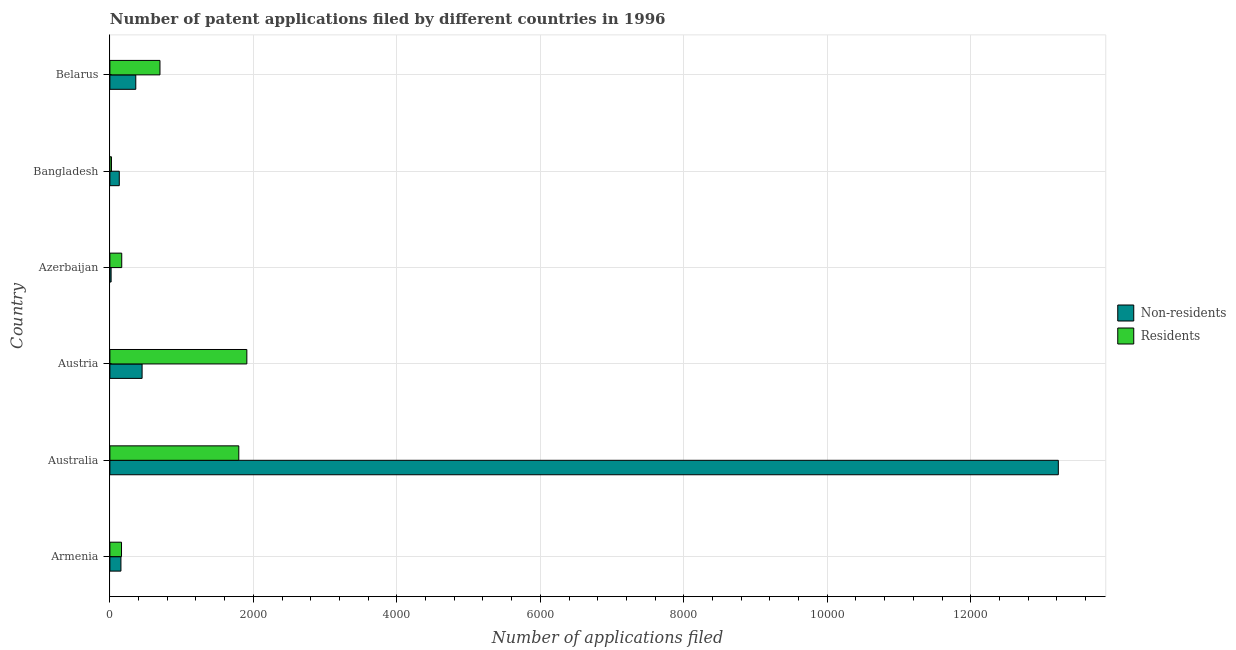How many groups of bars are there?
Ensure brevity in your answer.  6. Are the number of bars per tick equal to the number of legend labels?
Your response must be concise. Yes. Are the number of bars on each tick of the Y-axis equal?
Offer a terse response. Yes. How many bars are there on the 5th tick from the bottom?
Provide a succinct answer. 2. What is the label of the 3rd group of bars from the top?
Your answer should be very brief. Azerbaijan. What is the number of patent applications by residents in Armenia?
Keep it short and to the point. 162. Across all countries, what is the maximum number of patent applications by non residents?
Provide a succinct answer. 1.32e+04. Across all countries, what is the minimum number of patent applications by residents?
Ensure brevity in your answer.  22. In which country was the number of patent applications by non residents maximum?
Offer a very short reply. Australia. What is the total number of patent applications by residents in the graph?
Your answer should be very brief. 4753. What is the difference between the number of patent applications by residents in Australia and that in Belarus?
Provide a succinct answer. 1099. What is the difference between the number of patent applications by residents in Austria and the number of patent applications by non residents in Armenia?
Keep it short and to the point. 1755. What is the average number of patent applications by non residents per country?
Offer a terse response. 2388.83. What is the difference between the number of patent applications by residents and number of patent applications by non residents in Austria?
Give a very brief answer. 1460. In how many countries, is the number of patent applications by non residents greater than 8800 ?
Provide a succinct answer. 1. What is the ratio of the number of patent applications by non residents in Armenia to that in Australia?
Ensure brevity in your answer.  0.01. What is the difference between the highest and the second highest number of patent applications by residents?
Your answer should be very brief. 112. What is the difference between the highest and the lowest number of patent applications by non residents?
Give a very brief answer. 1.32e+04. Is the sum of the number of patent applications by non residents in Australia and Bangladesh greater than the maximum number of patent applications by residents across all countries?
Ensure brevity in your answer.  Yes. What does the 2nd bar from the top in Azerbaijan represents?
Your answer should be compact. Non-residents. What does the 2nd bar from the bottom in Austria represents?
Your answer should be compact. Residents. How many countries are there in the graph?
Provide a short and direct response. 6. Are the values on the major ticks of X-axis written in scientific E-notation?
Keep it short and to the point. No. Does the graph contain any zero values?
Your response must be concise. No. Does the graph contain grids?
Keep it short and to the point. Yes. How many legend labels are there?
Your answer should be very brief. 2. How are the legend labels stacked?
Your response must be concise. Vertical. What is the title of the graph?
Ensure brevity in your answer.  Number of patent applications filed by different countries in 1996. What is the label or title of the X-axis?
Ensure brevity in your answer.  Number of applications filed. What is the label or title of the Y-axis?
Your answer should be very brief. Country. What is the Number of applications filed of Non-residents in Armenia?
Offer a terse response. 154. What is the Number of applications filed of Residents in Armenia?
Offer a terse response. 162. What is the Number of applications filed of Non-residents in Australia?
Ensure brevity in your answer.  1.32e+04. What is the Number of applications filed of Residents in Australia?
Make the answer very short. 1797. What is the Number of applications filed in Non-residents in Austria?
Offer a terse response. 449. What is the Number of applications filed of Residents in Austria?
Provide a succinct answer. 1909. What is the Number of applications filed of Non-residents in Azerbaijan?
Your response must be concise. 17. What is the Number of applications filed of Residents in Azerbaijan?
Your answer should be very brief. 165. What is the Number of applications filed in Non-residents in Bangladesh?
Offer a very short reply. 131. What is the Number of applications filed of Residents in Bangladesh?
Offer a terse response. 22. What is the Number of applications filed in Non-residents in Belarus?
Make the answer very short. 361. What is the Number of applications filed of Residents in Belarus?
Offer a terse response. 698. Across all countries, what is the maximum Number of applications filed of Non-residents?
Give a very brief answer. 1.32e+04. Across all countries, what is the maximum Number of applications filed of Residents?
Ensure brevity in your answer.  1909. Across all countries, what is the minimum Number of applications filed of Residents?
Make the answer very short. 22. What is the total Number of applications filed of Non-residents in the graph?
Offer a very short reply. 1.43e+04. What is the total Number of applications filed in Residents in the graph?
Give a very brief answer. 4753. What is the difference between the Number of applications filed in Non-residents in Armenia and that in Australia?
Make the answer very short. -1.31e+04. What is the difference between the Number of applications filed in Residents in Armenia and that in Australia?
Offer a terse response. -1635. What is the difference between the Number of applications filed of Non-residents in Armenia and that in Austria?
Offer a terse response. -295. What is the difference between the Number of applications filed of Residents in Armenia and that in Austria?
Offer a terse response. -1747. What is the difference between the Number of applications filed of Non-residents in Armenia and that in Azerbaijan?
Give a very brief answer. 137. What is the difference between the Number of applications filed in Residents in Armenia and that in Bangladesh?
Keep it short and to the point. 140. What is the difference between the Number of applications filed in Non-residents in Armenia and that in Belarus?
Provide a succinct answer. -207. What is the difference between the Number of applications filed of Residents in Armenia and that in Belarus?
Keep it short and to the point. -536. What is the difference between the Number of applications filed in Non-residents in Australia and that in Austria?
Ensure brevity in your answer.  1.28e+04. What is the difference between the Number of applications filed in Residents in Australia and that in Austria?
Your answer should be compact. -112. What is the difference between the Number of applications filed of Non-residents in Australia and that in Azerbaijan?
Your answer should be compact. 1.32e+04. What is the difference between the Number of applications filed in Residents in Australia and that in Azerbaijan?
Give a very brief answer. 1632. What is the difference between the Number of applications filed in Non-residents in Australia and that in Bangladesh?
Offer a very short reply. 1.31e+04. What is the difference between the Number of applications filed in Residents in Australia and that in Bangladesh?
Make the answer very short. 1775. What is the difference between the Number of applications filed in Non-residents in Australia and that in Belarus?
Provide a short and direct response. 1.29e+04. What is the difference between the Number of applications filed in Residents in Australia and that in Belarus?
Offer a very short reply. 1099. What is the difference between the Number of applications filed of Non-residents in Austria and that in Azerbaijan?
Offer a terse response. 432. What is the difference between the Number of applications filed of Residents in Austria and that in Azerbaijan?
Your answer should be very brief. 1744. What is the difference between the Number of applications filed in Non-residents in Austria and that in Bangladesh?
Keep it short and to the point. 318. What is the difference between the Number of applications filed of Residents in Austria and that in Bangladesh?
Your answer should be very brief. 1887. What is the difference between the Number of applications filed in Non-residents in Austria and that in Belarus?
Ensure brevity in your answer.  88. What is the difference between the Number of applications filed in Residents in Austria and that in Belarus?
Your response must be concise. 1211. What is the difference between the Number of applications filed in Non-residents in Azerbaijan and that in Bangladesh?
Offer a very short reply. -114. What is the difference between the Number of applications filed in Residents in Azerbaijan and that in Bangladesh?
Offer a terse response. 143. What is the difference between the Number of applications filed of Non-residents in Azerbaijan and that in Belarus?
Offer a very short reply. -344. What is the difference between the Number of applications filed of Residents in Azerbaijan and that in Belarus?
Your response must be concise. -533. What is the difference between the Number of applications filed in Non-residents in Bangladesh and that in Belarus?
Keep it short and to the point. -230. What is the difference between the Number of applications filed of Residents in Bangladesh and that in Belarus?
Your response must be concise. -676. What is the difference between the Number of applications filed of Non-residents in Armenia and the Number of applications filed of Residents in Australia?
Your answer should be compact. -1643. What is the difference between the Number of applications filed in Non-residents in Armenia and the Number of applications filed in Residents in Austria?
Your answer should be compact. -1755. What is the difference between the Number of applications filed of Non-residents in Armenia and the Number of applications filed of Residents in Bangladesh?
Provide a succinct answer. 132. What is the difference between the Number of applications filed of Non-residents in Armenia and the Number of applications filed of Residents in Belarus?
Make the answer very short. -544. What is the difference between the Number of applications filed of Non-residents in Australia and the Number of applications filed of Residents in Austria?
Your answer should be very brief. 1.13e+04. What is the difference between the Number of applications filed of Non-residents in Australia and the Number of applications filed of Residents in Azerbaijan?
Your response must be concise. 1.31e+04. What is the difference between the Number of applications filed in Non-residents in Australia and the Number of applications filed in Residents in Bangladesh?
Your answer should be very brief. 1.32e+04. What is the difference between the Number of applications filed of Non-residents in Australia and the Number of applications filed of Residents in Belarus?
Give a very brief answer. 1.25e+04. What is the difference between the Number of applications filed of Non-residents in Austria and the Number of applications filed of Residents in Azerbaijan?
Ensure brevity in your answer.  284. What is the difference between the Number of applications filed in Non-residents in Austria and the Number of applications filed in Residents in Bangladesh?
Make the answer very short. 427. What is the difference between the Number of applications filed in Non-residents in Austria and the Number of applications filed in Residents in Belarus?
Your response must be concise. -249. What is the difference between the Number of applications filed of Non-residents in Azerbaijan and the Number of applications filed of Residents in Bangladesh?
Give a very brief answer. -5. What is the difference between the Number of applications filed in Non-residents in Azerbaijan and the Number of applications filed in Residents in Belarus?
Your response must be concise. -681. What is the difference between the Number of applications filed in Non-residents in Bangladesh and the Number of applications filed in Residents in Belarus?
Offer a terse response. -567. What is the average Number of applications filed in Non-residents per country?
Provide a short and direct response. 2388.83. What is the average Number of applications filed of Residents per country?
Your answer should be compact. 792.17. What is the difference between the Number of applications filed of Non-residents and Number of applications filed of Residents in Australia?
Provide a short and direct response. 1.14e+04. What is the difference between the Number of applications filed in Non-residents and Number of applications filed in Residents in Austria?
Make the answer very short. -1460. What is the difference between the Number of applications filed of Non-residents and Number of applications filed of Residents in Azerbaijan?
Make the answer very short. -148. What is the difference between the Number of applications filed in Non-residents and Number of applications filed in Residents in Bangladesh?
Your answer should be compact. 109. What is the difference between the Number of applications filed of Non-residents and Number of applications filed of Residents in Belarus?
Give a very brief answer. -337. What is the ratio of the Number of applications filed of Non-residents in Armenia to that in Australia?
Your answer should be compact. 0.01. What is the ratio of the Number of applications filed of Residents in Armenia to that in Australia?
Your response must be concise. 0.09. What is the ratio of the Number of applications filed of Non-residents in Armenia to that in Austria?
Your response must be concise. 0.34. What is the ratio of the Number of applications filed in Residents in Armenia to that in Austria?
Keep it short and to the point. 0.08. What is the ratio of the Number of applications filed of Non-residents in Armenia to that in Azerbaijan?
Offer a very short reply. 9.06. What is the ratio of the Number of applications filed in Residents in Armenia to that in Azerbaijan?
Offer a very short reply. 0.98. What is the ratio of the Number of applications filed of Non-residents in Armenia to that in Bangladesh?
Offer a terse response. 1.18. What is the ratio of the Number of applications filed in Residents in Armenia to that in Bangladesh?
Provide a short and direct response. 7.36. What is the ratio of the Number of applications filed of Non-residents in Armenia to that in Belarus?
Provide a short and direct response. 0.43. What is the ratio of the Number of applications filed in Residents in Armenia to that in Belarus?
Your answer should be compact. 0.23. What is the ratio of the Number of applications filed of Non-residents in Australia to that in Austria?
Provide a succinct answer. 29.45. What is the ratio of the Number of applications filed of Residents in Australia to that in Austria?
Provide a short and direct response. 0.94. What is the ratio of the Number of applications filed of Non-residents in Australia to that in Azerbaijan?
Make the answer very short. 777.71. What is the ratio of the Number of applications filed of Residents in Australia to that in Azerbaijan?
Offer a terse response. 10.89. What is the ratio of the Number of applications filed of Non-residents in Australia to that in Bangladesh?
Give a very brief answer. 100.92. What is the ratio of the Number of applications filed in Residents in Australia to that in Bangladesh?
Ensure brevity in your answer.  81.68. What is the ratio of the Number of applications filed of Non-residents in Australia to that in Belarus?
Keep it short and to the point. 36.62. What is the ratio of the Number of applications filed in Residents in Australia to that in Belarus?
Your response must be concise. 2.57. What is the ratio of the Number of applications filed in Non-residents in Austria to that in Azerbaijan?
Your response must be concise. 26.41. What is the ratio of the Number of applications filed in Residents in Austria to that in Azerbaijan?
Offer a very short reply. 11.57. What is the ratio of the Number of applications filed of Non-residents in Austria to that in Bangladesh?
Make the answer very short. 3.43. What is the ratio of the Number of applications filed of Residents in Austria to that in Bangladesh?
Keep it short and to the point. 86.77. What is the ratio of the Number of applications filed of Non-residents in Austria to that in Belarus?
Your answer should be very brief. 1.24. What is the ratio of the Number of applications filed in Residents in Austria to that in Belarus?
Your answer should be compact. 2.73. What is the ratio of the Number of applications filed of Non-residents in Azerbaijan to that in Bangladesh?
Make the answer very short. 0.13. What is the ratio of the Number of applications filed in Non-residents in Azerbaijan to that in Belarus?
Ensure brevity in your answer.  0.05. What is the ratio of the Number of applications filed in Residents in Azerbaijan to that in Belarus?
Your answer should be very brief. 0.24. What is the ratio of the Number of applications filed of Non-residents in Bangladesh to that in Belarus?
Offer a terse response. 0.36. What is the ratio of the Number of applications filed in Residents in Bangladesh to that in Belarus?
Your answer should be compact. 0.03. What is the difference between the highest and the second highest Number of applications filed of Non-residents?
Offer a very short reply. 1.28e+04. What is the difference between the highest and the second highest Number of applications filed in Residents?
Your answer should be compact. 112. What is the difference between the highest and the lowest Number of applications filed in Non-residents?
Give a very brief answer. 1.32e+04. What is the difference between the highest and the lowest Number of applications filed in Residents?
Make the answer very short. 1887. 